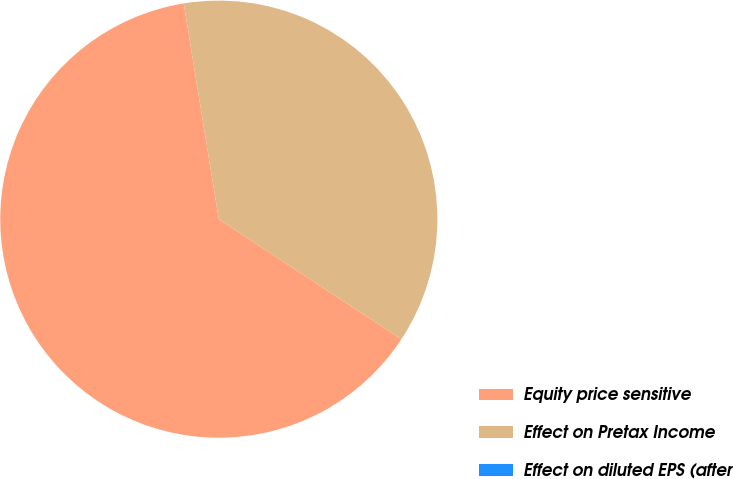Convert chart to OTSL. <chart><loc_0><loc_0><loc_500><loc_500><pie_chart><fcel>Equity price sensitive<fcel>Effect on Pretax Income<fcel>Effect on diluted EPS (after<nl><fcel>63.17%<fcel>36.83%<fcel>0.0%<nl></chart> 